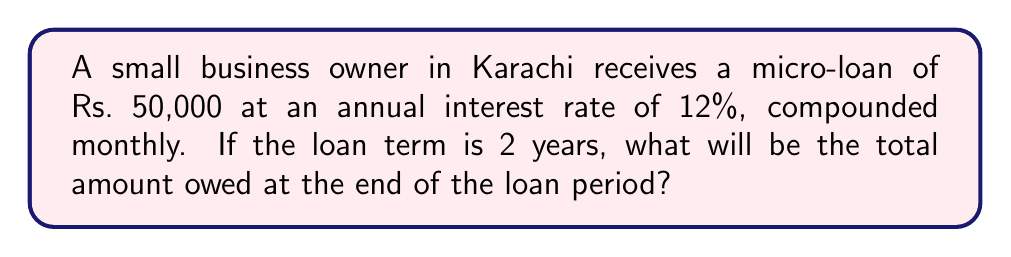What is the answer to this math problem? Let's solve this problem step by step using the compound interest formula:

$$A = P(1 + \frac{r}{n})^{nt}$$

Where:
$A$ = final amount
$P$ = principal (initial loan amount)
$r$ = annual interest rate (in decimal form)
$n$ = number of times interest is compounded per year
$t$ = number of years

Given:
$P = 50,000$ Rs
$r = 12\% = 0.12$
$n = 12$ (compounded monthly)
$t = 2$ years

Step 1: Plug the values into the formula
$$A = 50,000(1 + \frac{0.12}{12})^{12 \cdot 2}$$

Step 2: Simplify the expression inside the parentheses
$$A = 50,000(1 + 0.01)^{24}$$

Step 3: Calculate the exponent
$$A = 50,000(1.01)^{24}$$

Step 4: Use a calculator to compute the result
$$A = 50,000 \cdot 1.2697$$
$$A = 63,485.37$$

Therefore, the total amount owed after 2 years will be Rs. 63,485.37.
Answer: Rs. 63,485.37 